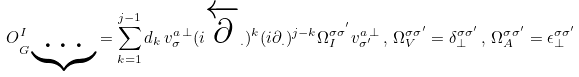Convert formula to latex. <formula><loc_0><loc_0><loc_500><loc_500>O _ { G \underbrace { \cdots } } ^ { I } = \sum _ { k = 1 } ^ { j - 1 } d _ { k } \, v _ { \sigma } ^ { a \, \perp } ( i \overleftarrow { \partial } _ { . } ) ^ { k } ( i \partial _ { . } ) ^ { j - k } \Omega _ { I } ^ { \sigma \sigma ^ { ^ { \prime } } } v _ { \sigma ^ { \prime } } ^ { a \, \perp } \, , \, \Omega _ { V } ^ { \sigma \sigma ^ { \prime } } = \delta _ { \perp } ^ { \sigma \sigma ^ { \prime } } \, , \, \Omega _ { A } ^ { \sigma \sigma ^ { \prime } } = \epsilon _ { \perp } ^ { \sigma \sigma ^ { \prime } }</formula> 